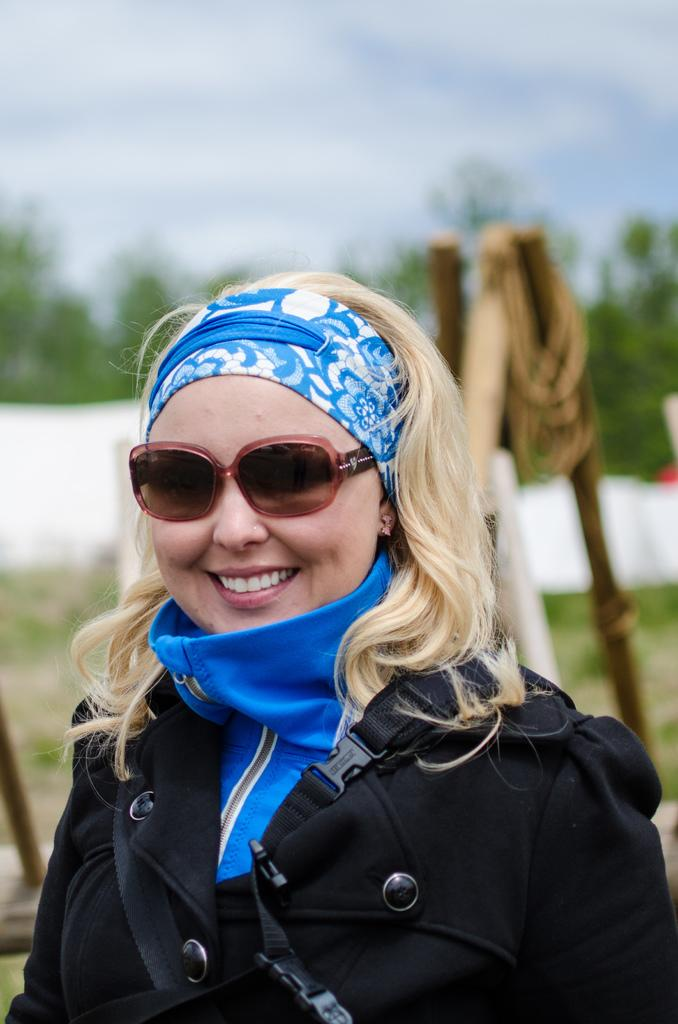Who is the main subject in the image? There is a lady in the image. What is the lady doing in the image? The lady is standing. What is the lady wearing in the image? The lady is wearing a coat and glasses. Can you describe the background of the image? The background of the image is blurred. Where is the mailbox located in the image? There is no mailbox present in the image. What type of kite is the lady holding in the image? There is no kite present in the image. 